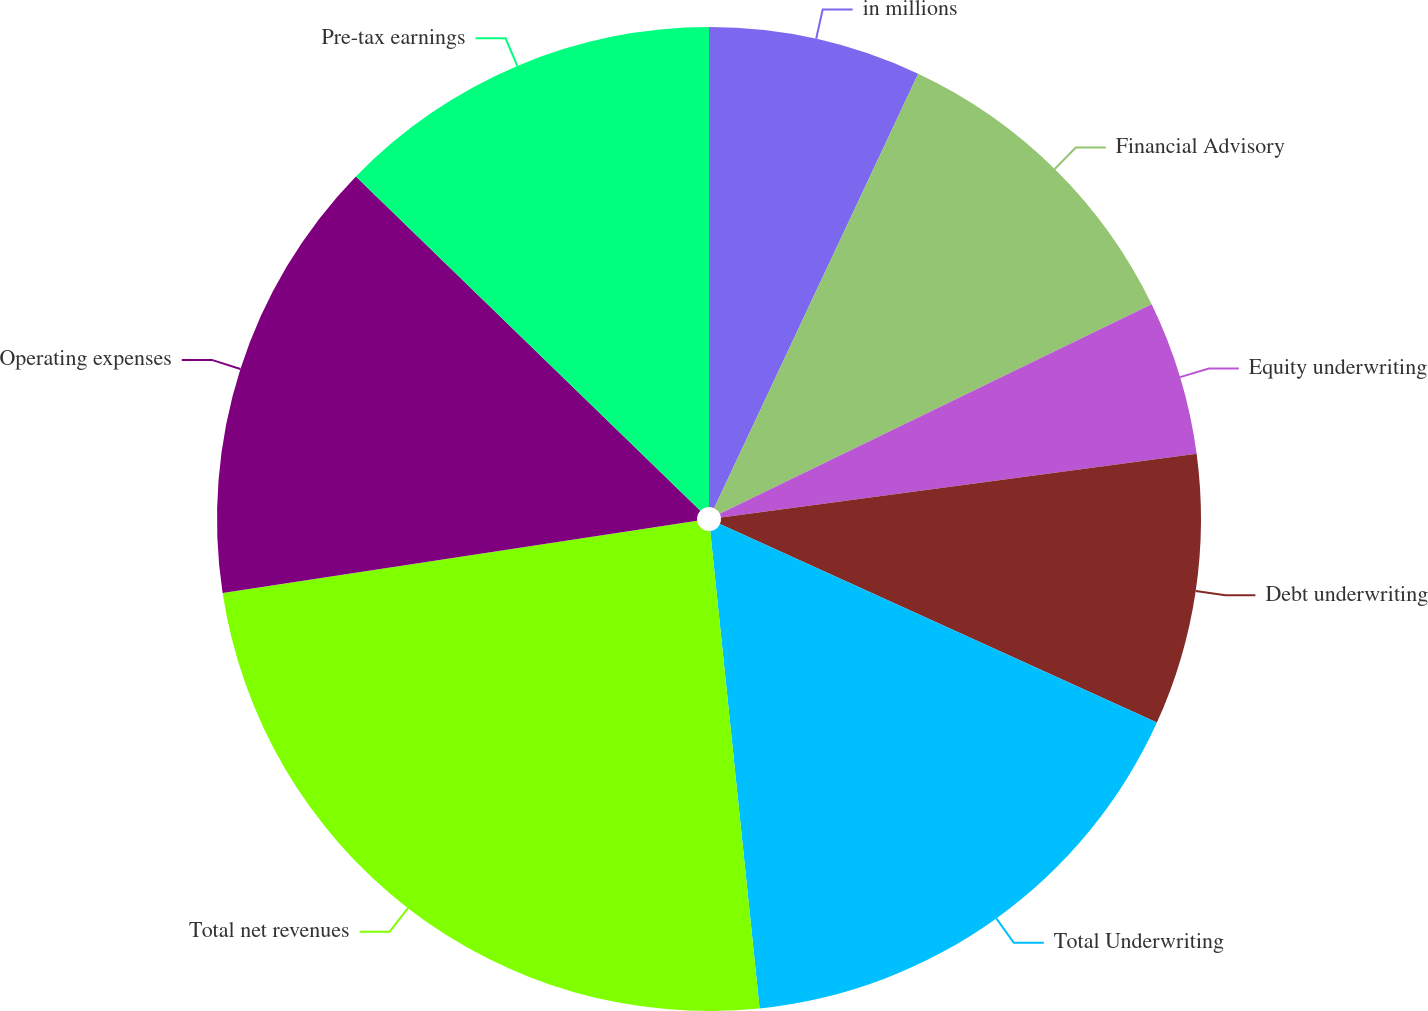Convert chart. <chart><loc_0><loc_0><loc_500><loc_500><pie_chart><fcel>in millions<fcel>Financial Advisory<fcel>Equity underwriting<fcel>Debt underwriting<fcel>Total Underwriting<fcel>Total net revenues<fcel>Operating expenses<fcel>Pre-tax earnings<nl><fcel>6.99%<fcel>10.82%<fcel>5.07%<fcel>8.91%<fcel>16.57%<fcel>24.24%<fcel>14.66%<fcel>12.74%<nl></chart> 